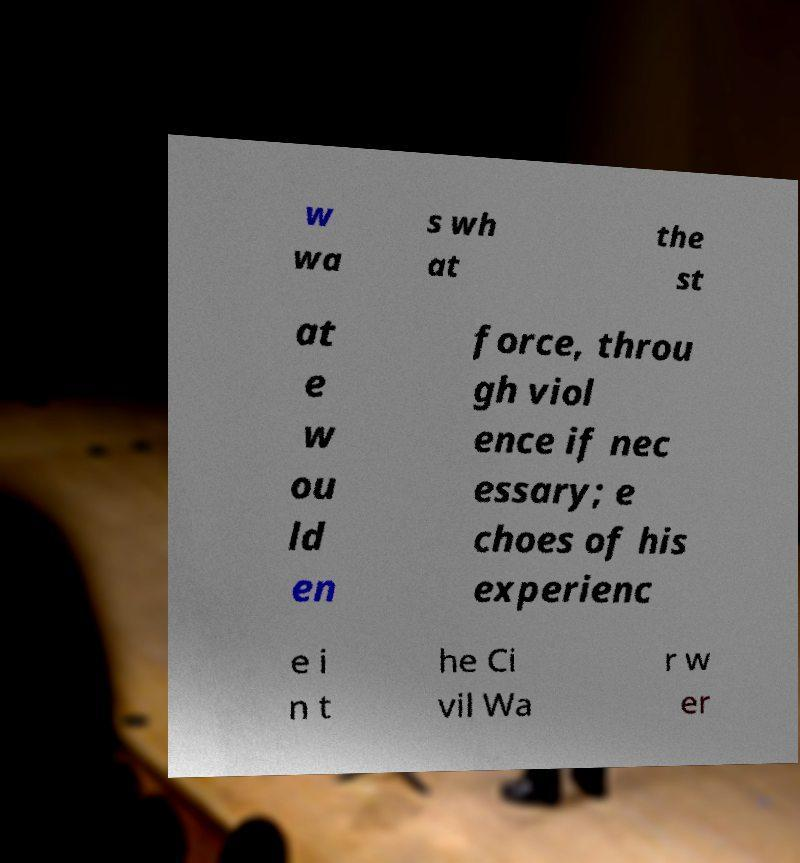Could you extract and type out the text from this image? w wa s wh at the st at e w ou ld en force, throu gh viol ence if nec essary; e choes of his experienc e i n t he Ci vil Wa r w er 